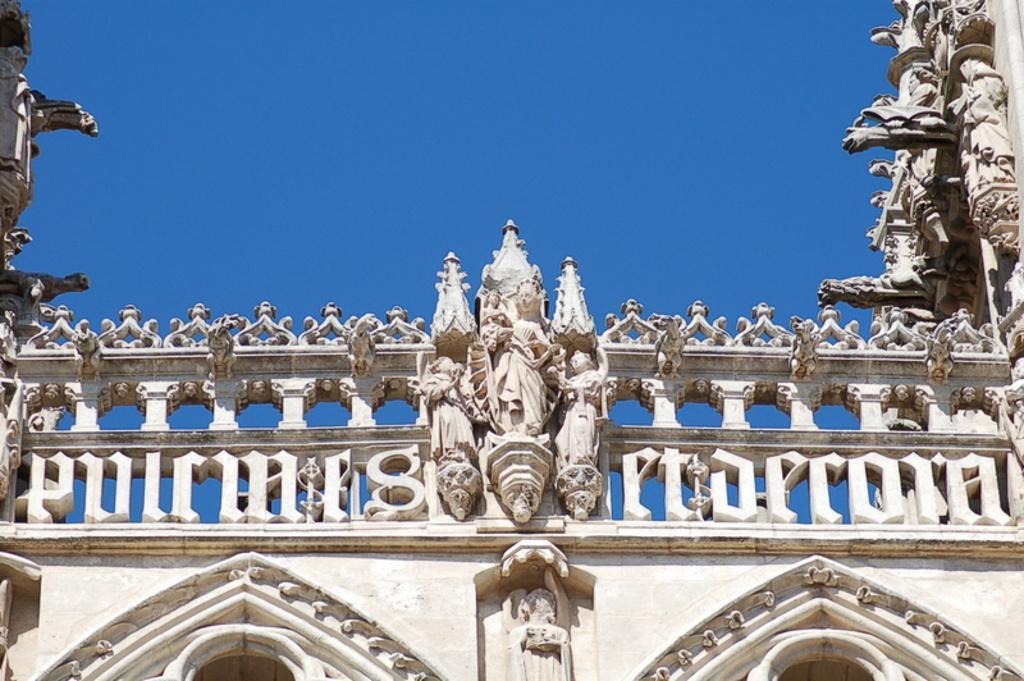In one or two sentences, can you explain what this image depicts? In this image I can see a building and few statutes are on it. It is in cream color. The sky is in blue color. 